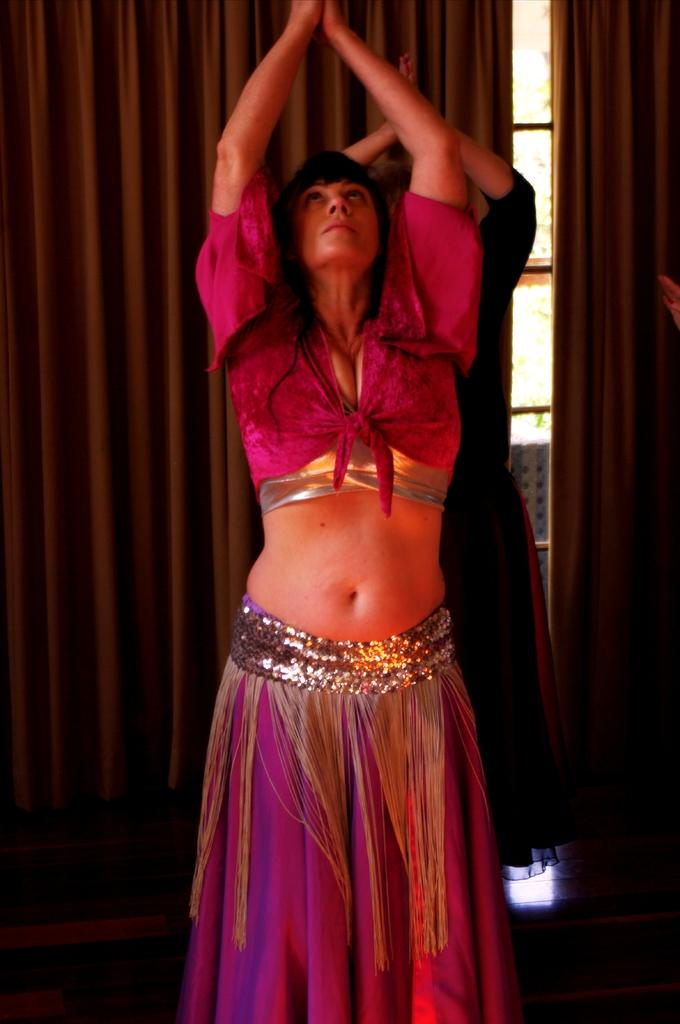Who is the main subject in the image? There is a lady in the image. Can you describe the background of the image? There is a person, a curtain, a glass window, and other objects in the background of the image. How many people are visible in the image? There is one lady and one person in the image. What type of window is present in the background? There is a glass window in the background of the image. What type of skin condition can be seen on the lady's face in the image? There is no indication of a skin condition on the lady's face in the image. Is there any evidence of an attack in the image? There is no indication of an attack or any violent activity in the image. 